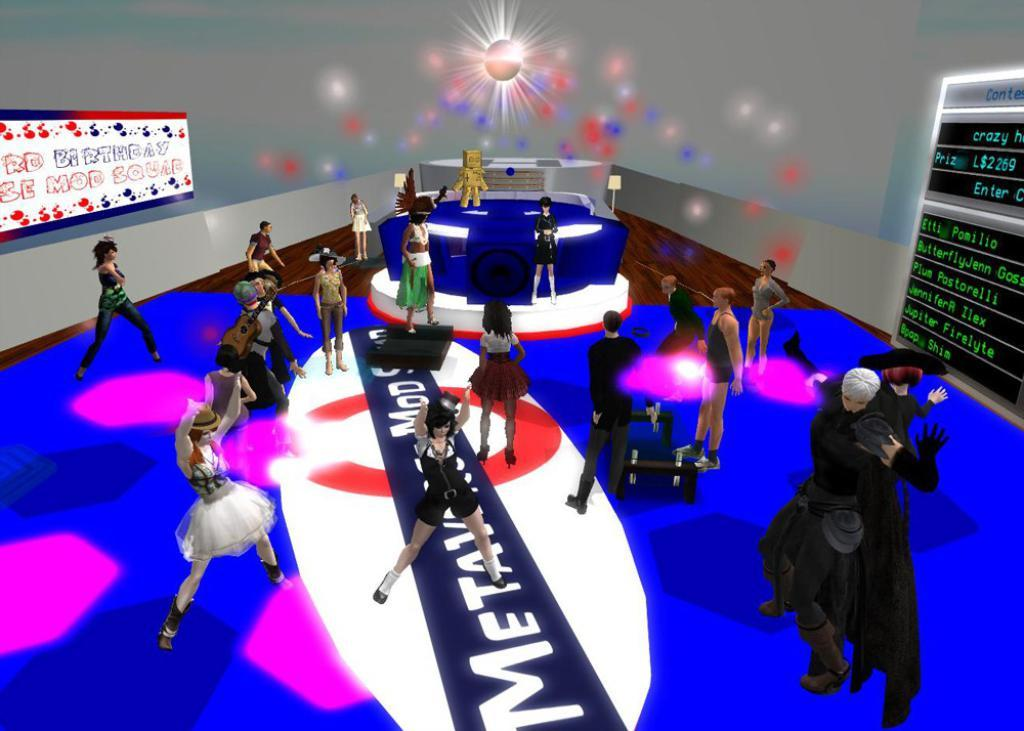What are the people in the image doing? The people in the image are dancing. Where are the people dancing? The people are dancing on the floor. Can you describe any musical instruments in the image? Yes, there is a person carrying a guitar in the image. What is on the right side of the image? There is an LCD screen on the right side of the image. What type of trouble is the person with the guitar experiencing in the image? There is no indication of trouble in the image; the person with the guitar is simply carrying it. 